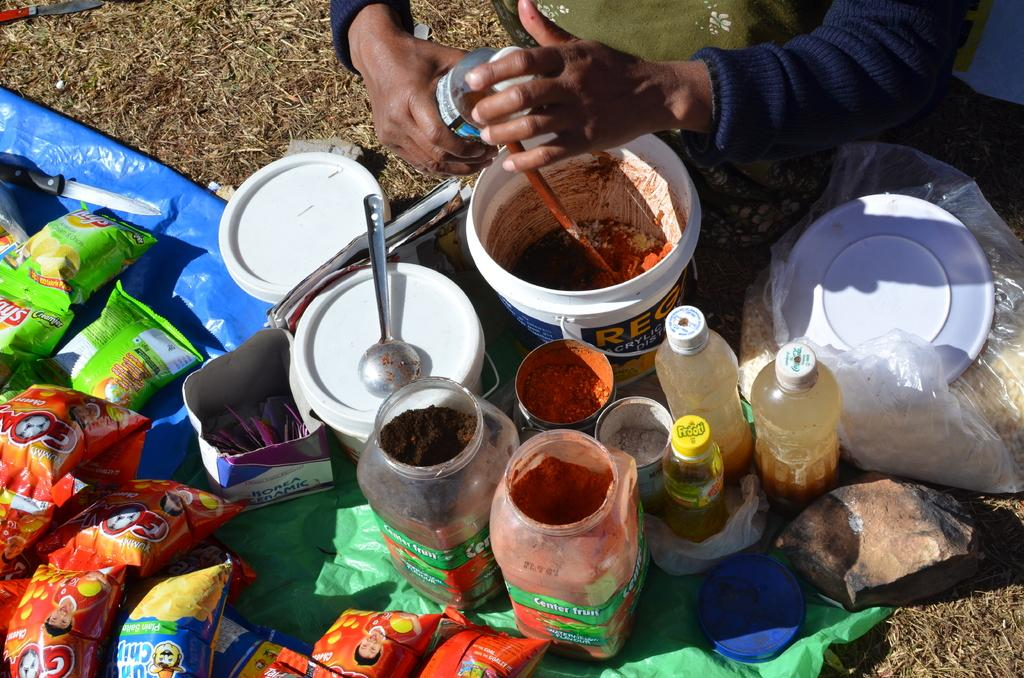What can be seen in the image? There is a person in the image. What is the person holding in his hand? The person is holding a bottle in his hand. What other items are present in front of the person? There are a few jars and sachets in front of the person. What type of brush is the person using to rub the crib in the image? There is no crib or brush present in the image. 